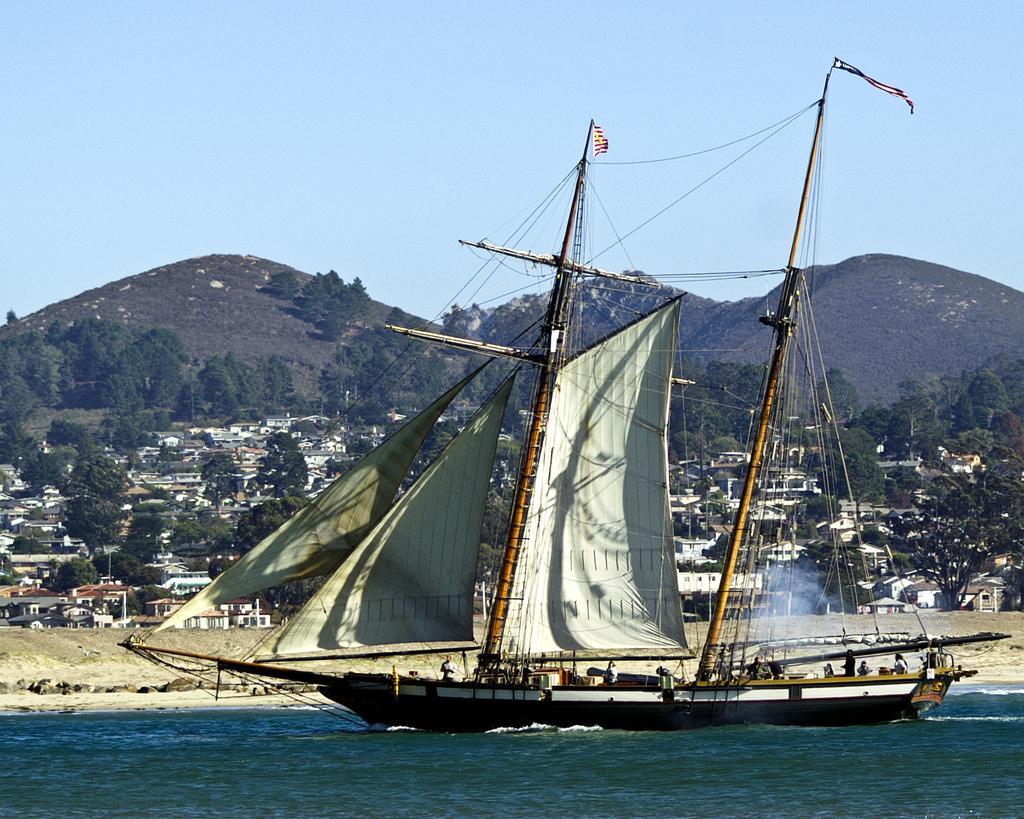Could you give a brief overview of what you see in this image? In the image there is a ship with masts and poles, it is on the water surface and there are few people inside the ship, in the background there are many houses, trees and mountains. 